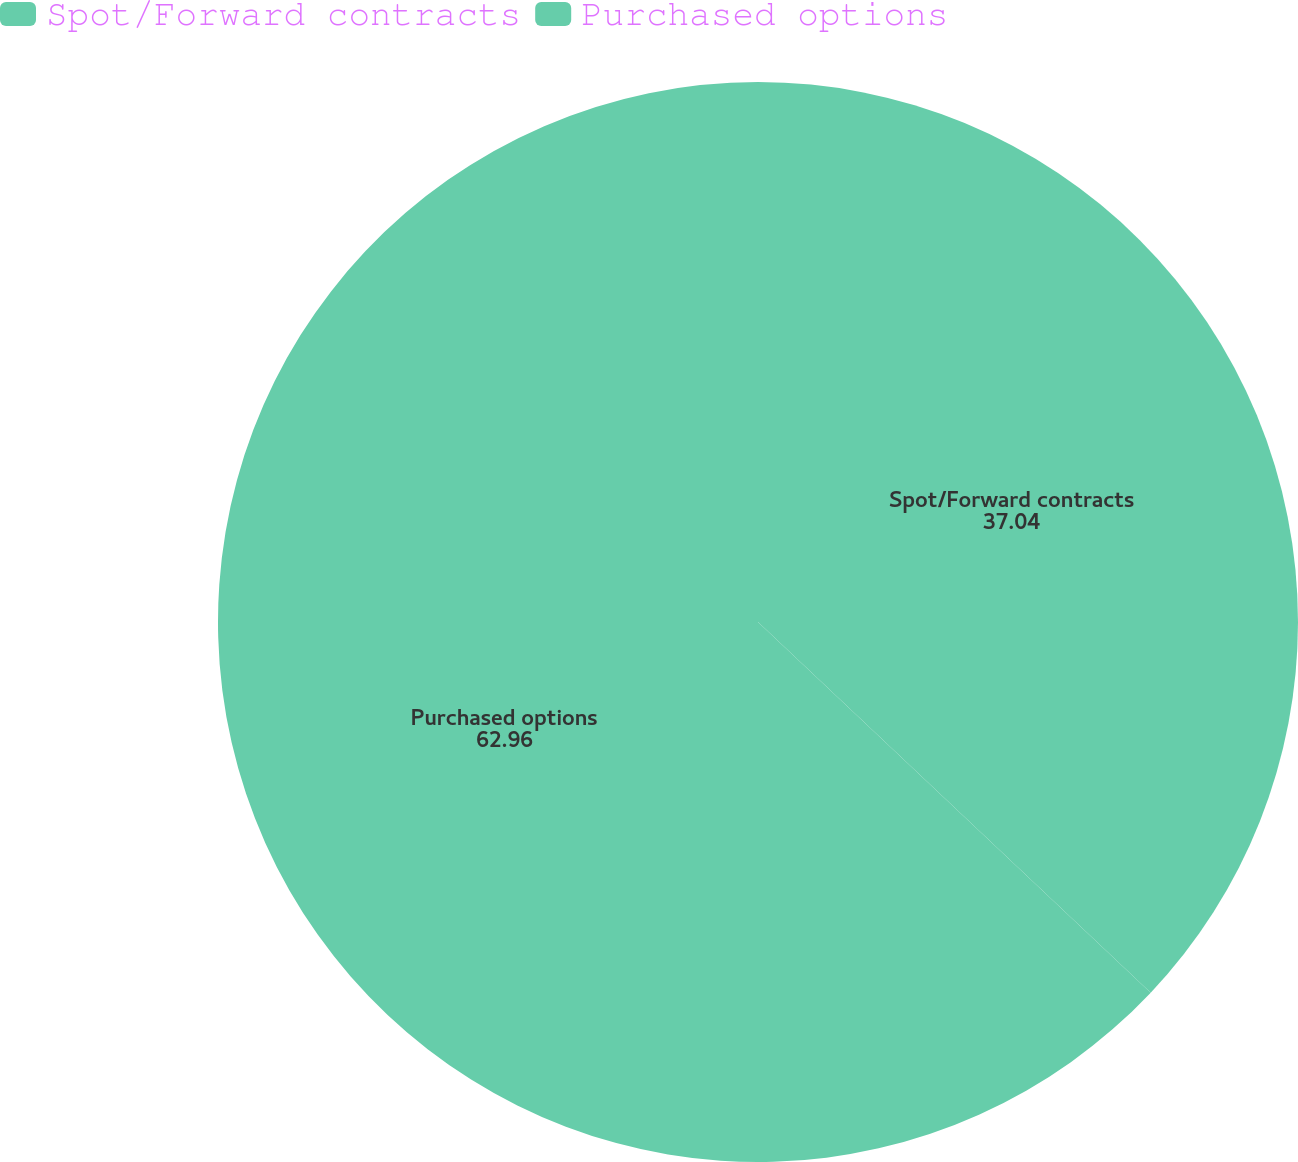Convert chart. <chart><loc_0><loc_0><loc_500><loc_500><pie_chart><fcel>Spot/Forward contracts<fcel>Purchased options<nl><fcel>37.04%<fcel>62.96%<nl></chart> 